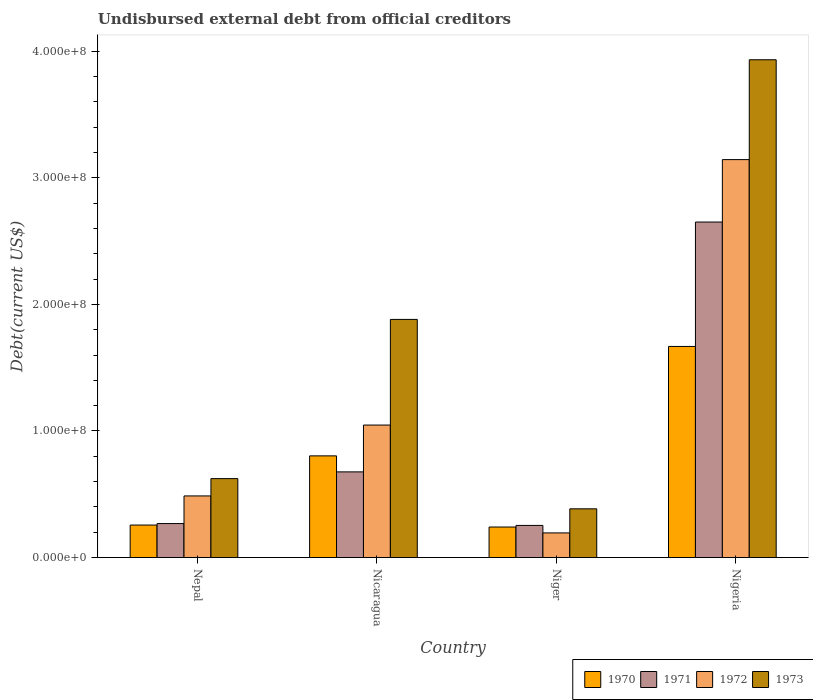How many different coloured bars are there?
Keep it short and to the point. 4. How many groups of bars are there?
Keep it short and to the point. 4. Are the number of bars on each tick of the X-axis equal?
Ensure brevity in your answer.  Yes. What is the label of the 3rd group of bars from the left?
Keep it short and to the point. Niger. What is the total debt in 1971 in Niger?
Provide a short and direct response. 2.54e+07. Across all countries, what is the maximum total debt in 1971?
Keep it short and to the point. 2.65e+08. Across all countries, what is the minimum total debt in 1972?
Provide a short and direct response. 1.94e+07. In which country was the total debt in 1972 maximum?
Your answer should be very brief. Nigeria. In which country was the total debt in 1971 minimum?
Your answer should be compact. Niger. What is the total total debt in 1971 in the graph?
Make the answer very short. 3.85e+08. What is the difference between the total debt in 1971 in Nepal and that in Nigeria?
Ensure brevity in your answer.  -2.38e+08. What is the difference between the total debt in 1971 in Nicaragua and the total debt in 1972 in Nigeria?
Keep it short and to the point. -2.47e+08. What is the average total debt in 1970 per country?
Your response must be concise. 7.42e+07. What is the difference between the total debt of/in 1973 and total debt of/in 1971 in Nicaragua?
Offer a terse response. 1.20e+08. In how many countries, is the total debt in 1973 greater than 40000000 US$?
Your response must be concise. 3. What is the ratio of the total debt in 1970 in Niger to that in Nigeria?
Offer a very short reply. 0.14. Is the difference between the total debt in 1973 in Nicaragua and Nigeria greater than the difference between the total debt in 1971 in Nicaragua and Nigeria?
Ensure brevity in your answer.  No. What is the difference between the highest and the second highest total debt in 1971?
Your answer should be very brief. 1.97e+08. What is the difference between the highest and the lowest total debt in 1970?
Keep it short and to the point. 1.43e+08. In how many countries, is the total debt in 1971 greater than the average total debt in 1971 taken over all countries?
Your answer should be compact. 1. Is it the case that in every country, the sum of the total debt in 1972 and total debt in 1973 is greater than the sum of total debt in 1971 and total debt in 1970?
Provide a short and direct response. No. What does the 3rd bar from the left in Nepal represents?
Keep it short and to the point. 1972. Is it the case that in every country, the sum of the total debt in 1970 and total debt in 1971 is greater than the total debt in 1972?
Offer a terse response. Yes. How many countries are there in the graph?
Keep it short and to the point. 4. What is the difference between two consecutive major ticks on the Y-axis?
Give a very brief answer. 1.00e+08. Are the values on the major ticks of Y-axis written in scientific E-notation?
Provide a short and direct response. Yes. Does the graph contain grids?
Make the answer very short. No. What is the title of the graph?
Ensure brevity in your answer.  Undisbursed external debt from official creditors. Does "2014" appear as one of the legend labels in the graph?
Provide a short and direct response. No. What is the label or title of the X-axis?
Make the answer very short. Country. What is the label or title of the Y-axis?
Your answer should be compact. Debt(current US$). What is the Debt(current US$) of 1970 in Nepal?
Provide a succinct answer. 2.57e+07. What is the Debt(current US$) in 1971 in Nepal?
Keep it short and to the point. 2.68e+07. What is the Debt(current US$) in 1972 in Nepal?
Give a very brief answer. 4.87e+07. What is the Debt(current US$) in 1973 in Nepal?
Offer a terse response. 6.23e+07. What is the Debt(current US$) in 1970 in Nicaragua?
Offer a very short reply. 8.03e+07. What is the Debt(current US$) in 1971 in Nicaragua?
Make the answer very short. 6.77e+07. What is the Debt(current US$) in 1972 in Nicaragua?
Provide a succinct answer. 1.05e+08. What is the Debt(current US$) in 1973 in Nicaragua?
Provide a succinct answer. 1.88e+08. What is the Debt(current US$) of 1970 in Niger?
Make the answer very short. 2.41e+07. What is the Debt(current US$) of 1971 in Niger?
Your response must be concise. 2.54e+07. What is the Debt(current US$) of 1972 in Niger?
Provide a succinct answer. 1.94e+07. What is the Debt(current US$) of 1973 in Niger?
Offer a very short reply. 3.85e+07. What is the Debt(current US$) in 1970 in Nigeria?
Your answer should be compact. 1.67e+08. What is the Debt(current US$) of 1971 in Nigeria?
Your response must be concise. 2.65e+08. What is the Debt(current US$) in 1972 in Nigeria?
Offer a very short reply. 3.14e+08. What is the Debt(current US$) in 1973 in Nigeria?
Your answer should be compact. 3.93e+08. Across all countries, what is the maximum Debt(current US$) in 1970?
Keep it short and to the point. 1.67e+08. Across all countries, what is the maximum Debt(current US$) in 1971?
Make the answer very short. 2.65e+08. Across all countries, what is the maximum Debt(current US$) of 1972?
Your answer should be very brief. 3.14e+08. Across all countries, what is the maximum Debt(current US$) in 1973?
Your response must be concise. 3.93e+08. Across all countries, what is the minimum Debt(current US$) of 1970?
Make the answer very short. 2.41e+07. Across all countries, what is the minimum Debt(current US$) in 1971?
Provide a succinct answer. 2.54e+07. Across all countries, what is the minimum Debt(current US$) in 1972?
Offer a very short reply. 1.94e+07. Across all countries, what is the minimum Debt(current US$) of 1973?
Your response must be concise. 3.85e+07. What is the total Debt(current US$) in 1970 in the graph?
Offer a terse response. 2.97e+08. What is the total Debt(current US$) in 1971 in the graph?
Your answer should be compact. 3.85e+08. What is the total Debt(current US$) of 1972 in the graph?
Offer a terse response. 4.87e+08. What is the total Debt(current US$) in 1973 in the graph?
Offer a terse response. 6.82e+08. What is the difference between the Debt(current US$) in 1970 in Nepal and that in Nicaragua?
Your answer should be very brief. -5.47e+07. What is the difference between the Debt(current US$) in 1971 in Nepal and that in Nicaragua?
Your answer should be compact. -4.08e+07. What is the difference between the Debt(current US$) in 1972 in Nepal and that in Nicaragua?
Your response must be concise. -5.60e+07. What is the difference between the Debt(current US$) in 1973 in Nepal and that in Nicaragua?
Your answer should be very brief. -1.26e+08. What is the difference between the Debt(current US$) of 1970 in Nepal and that in Niger?
Ensure brevity in your answer.  1.55e+06. What is the difference between the Debt(current US$) of 1971 in Nepal and that in Niger?
Your response must be concise. 1.45e+06. What is the difference between the Debt(current US$) of 1972 in Nepal and that in Niger?
Keep it short and to the point. 2.92e+07. What is the difference between the Debt(current US$) in 1973 in Nepal and that in Niger?
Your answer should be compact. 2.39e+07. What is the difference between the Debt(current US$) in 1970 in Nepal and that in Nigeria?
Your answer should be very brief. -1.41e+08. What is the difference between the Debt(current US$) of 1971 in Nepal and that in Nigeria?
Give a very brief answer. -2.38e+08. What is the difference between the Debt(current US$) of 1972 in Nepal and that in Nigeria?
Keep it short and to the point. -2.66e+08. What is the difference between the Debt(current US$) of 1973 in Nepal and that in Nigeria?
Provide a short and direct response. -3.31e+08. What is the difference between the Debt(current US$) in 1970 in Nicaragua and that in Niger?
Give a very brief answer. 5.62e+07. What is the difference between the Debt(current US$) of 1971 in Nicaragua and that in Niger?
Your answer should be compact. 4.23e+07. What is the difference between the Debt(current US$) of 1972 in Nicaragua and that in Niger?
Your answer should be compact. 8.52e+07. What is the difference between the Debt(current US$) in 1973 in Nicaragua and that in Niger?
Give a very brief answer. 1.50e+08. What is the difference between the Debt(current US$) in 1970 in Nicaragua and that in Nigeria?
Offer a very short reply. -8.65e+07. What is the difference between the Debt(current US$) of 1971 in Nicaragua and that in Nigeria?
Your answer should be very brief. -1.97e+08. What is the difference between the Debt(current US$) of 1972 in Nicaragua and that in Nigeria?
Offer a very short reply. -2.10e+08. What is the difference between the Debt(current US$) in 1973 in Nicaragua and that in Nigeria?
Your answer should be compact. -2.05e+08. What is the difference between the Debt(current US$) in 1970 in Niger and that in Nigeria?
Ensure brevity in your answer.  -1.43e+08. What is the difference between the Debt(current US$) in 1971 in Niger and that in Nigeria?
Your response must be concise. -2.40e+08. What is the difference between the Debt(current US$) of 1972 in Niger and that in Nigeria?
Provide a succinct answer. -2.95e+08. What is the difference between the Debt(current US$) of 1973 in Niger and that in Nigeria?
Your answer should be compact. -3.55e+08. What is the difference between the Debt(current US$) in 1970 in Nepal and the Debt(current US$) in 1971 in Nicaragua?
Make the answer very short. -4.20e+07. What is the difference between the Debt(current US$) of 1970 in Nepal and the Debt(current US$) of 1972 in Nicaragua?
Keep it short and to the point. -7.90e+07. What is the difference between the Debt(current US$) of 1970 in Nepal and the Debt(current US$) of 1973 in Nicaragua?
Your answer should be compact. -1.62e+08. What is the difference between the Debt(current US$) of 1971 in Nepal and the Debt(current US$) of 1972 in Nicaragua?
Offer a terse response. -7.78e+07. What is the difference between the Debt(current US$) in 1971 in Nepal and the Debt(current US$) in 1973 in Nicaragua?
Keep it short and to the point. -1.61e+08. What is the difference between the Debt(current US$) of 1972 in Nepal and the Debt(current US$) of 1973 in Nicaragua?
Give a very brief answer. -1.39e+08. What is the difference between the Debt(current US$) of 1970 in Nepal and the Debt(current US$) of 1971 in Niger?
Your response must be concise. 2.78e+05. What is the difference between the Debt(current US$) in 1970 in Nepal and the Debt(current US$) in 1972 in Niger?
Ensure brevity in your answer.  6.20e+06. What is the difference between the Debt(current US$) of 1970 in Nepal and the Debt(current US$) of 1973 in Niger?
Make the answer very short. -1.28e+07. What is the difference between the Debt(current US$) in 1971 in Nepal and the Debt(current US$) in 1972 in Niger?
Give a very brief answer. 7.37e+06. What is the difference between the Debt(current US$) in 1971 in Nepal and the Debt(current US$) in 1973 in Niger?
Offer a terse response. -1.17e+07. What is the difference between the Debt(current US$) in 1972 in Nepal and the Debt(current US$) in 1973 in Niger?
Your answer should be compact. 1.02e+07. What is the difference between the Debt(current US$) in 1970 in Nepal and the Debt(current US$) in 1971 in Nigeria?
Your response must be concise. -2.39e+08. What is the difference between the Debt(current US$) of 1970 in Nepal and the Debt(current US$) of 1972 in Nigeria?
Ensure brevity in your answer.  -2.89e+08. What is the difference between the Debt(current US$) in 1970 in Nepal and the Debt(current US$) in 1973 in Nigeria?
Provide a succinct answer. -3.68e+08. What is the difference between the Debt(current US$) in 1971 in Nepal and the Debt(current US$) in 1972 in Nigeria?
Your response must be concise. -2.88e+08. What is the difference between the Debt(current US$) in 1971 in Nepal and the Debt(current US$) in 1973 in Nigeria?
Give a very brief answer. -3.66e+08. What is the difference between the Debt(current US$) in 1972 in Nepal and the Debt(current US$) in 1973 in Nigeria?
Provide a succinct answer. -3.45e+08. What is the difference between the Debt(current US$) in 1970 in Nicaragua and the Debt(current US$) in 1971 in Niger?
Your response must be concise. 5.49e+07. What is the difference between the Debt(current US$) of 1970 in Nicaragua and the Debt(current US$) of 1972 in Niger?
Your answer should be compact. 6.09e+07. What is the difference between the Debt(current US$) of 1970 in Nicaragua and the Debt(current US$) of 1973 in Niger?
Your response must be concise. 4.18e+07. What is the difference between the Debt(current US$) in 1971 in Nicaragua and the Debt(current US$) in 1972 in Niger?
Ensure brevity in your answer.  4.82e+07. What is the difference between the Debt(current US$) of 1971 in Nicaragua and the Debt(current US$) of 1973 in Niger?
Make the answer very short. 2.92e+07. What is the difference between the Debt(current US$) in 1972 in Nicaragua and the Debt(current US$) in 1973 in Niger?
Your answer should be very brief. 6.62e+07. What is the difference between the Debt(current US$) of 1970 in Nicaragua and the Debt(current US$) of 1971 in Nigeria?
Ensure brevity in your answer.  -1.85e+08. What is the difference between the Debt(current US$) of 1970 in Nicaragua and the Debt(current US$) of 1972 in Nigeria?
Your answer should be compact. -2.34e+08. What is the difference between the Debt(current US$) in 1970 in Nicaragua and the Debt(current US$) in 1973 in Nigeria?
Offer a very short reply. -3.13e+08. What is the difference between the Debt(current US$) of 1971 in Nicaragua and the Debt(current US$) of 1972 in Nigeria?
Your answer should be compact. -2.47e+08. What is the difference between the Debt(current US$) of 1971 in Nicaragua and the Debt(current US$) of 1973 in Nigeria?
Your answer should be compact. -3.26e+08. What is the difference between the Debt(current US$) of 1972 in Nicaragua and the Debt(current US$) of 1973 in Nigeria?
Offer a terse response. -2.89e+08. What is the difference between the Debt(current US$) in 1970 in Niger and the Debt(current US$) in 1971 in Nigeria?
Offer a very short reply. -2.41e+08. What is the difference between the Debt(current US$) of 1970 in Niger and the Debt(current US$) of 1972 in Nigeria?
Provide a short and direct response. -2.90e+08. What is the difference between the Debt(current US$) in 1970 in Niger and the Debt(current US$) in 1973 in Nigeria?
Your answer should be compact. -3.69e+08. What is the difference between the Debt(current US$) in 1971 in Niger and the Debt(current US$) in 1972 in Nigeria?
Ensure brevity in your answer.  -2.89e+08. What is the difference between the Debt(current US$) in 1971 in Niger and the Debt(current US$) in 1973 in Nigeria?
Offer a terse response. -3.68e+08. What is the difference between the Debt(current US$) in 1972 in Niger and the Debt(current US$) in 1973 in Nigeria?
Keep it short and to the point. -3.74e+08. What is the average Debt(current US$) of 1970 per country?
Give a very brief answer. 7.42e+07. What is the average Debt(current US$) of 1971 per country?
Keep it short and to the point. 9.62e+07. What is the average Debt(current US$) of 1972 per country?
Offer a terse response. 1.22e+08. What is the average Debt(current US$) of 1973 per country?
Ensure brevity in your answer.  1.71e+08. What is the difference between the Debt(current US$) of 1970 and Debt(current US$) of 1971 in Nepal?
Make the answer very short. -1.17e+06. What is the difference between the Debt(current US$) in 1970 and Debt(current US$) in 1972 in Nepal?
Offer a very short reply. -2.30e+07. What is the difference between the Debt(current US$) in 1970 and Debt(current US$) in 1973 in Nepal?
Your response must be concise. -3.67e+07. What is the difference between the Debt(current US$) in 1971 and Debt(current US$) in 1972 in Nepal?
Ensure brevity in your answer.  -2.18e+07. What is the difference between the Debt(current US$) in 1971 and Debt(current US$) in 1973 in Nepal?
Give a very brief answer. -3.55e+07. What is the difference between the Debt(current US$) in 1972 and Debt(current US$) in 1973 in Nepal?
Make the answer very short. -1.37e+07. What is the difference between the Debt(current US$) of 1970 and Debt(current US$) of 1971 in Nicaragua?
Provide a succinct answer. 1.26e+07. What is the difference between the Debt(current US$) in 1970 and Debt(current US$) in 1972 in Nicaragua?
Offer a very short reply. -2.44e+07. What is the difference between the Debt(current US$) in 1970 and Debt(current US$) in 1973 in Nicaragua?
Offer a terse response. -1.08e+08. What is the difference between the Debt(current US$) in 1971 and Debt(current US$) in 1972 in Nicaragua?
Your answer should be compact. -3.70e+07. What is the difference between the Debt(current US$) in 1971 and Debt(current US$) in 1973 in Nicaragua?
Your answer should be compact. -1.20e+08. What is the difference between the Debt(current US$) of 1972 and Debt(current US$) of 1973 in Nicaragua?
Offer a very short reply. -8.35e+07. What is the difference between the Debt(current US$) in 1970 and Debt(current US$) in 1971 in Niger?
Offer a terse response. -1.28e+06. What is the difference between the Debt(current US$) of 1970 and Debt(current US$) of 1972 in Niger?
Your response must be concise. 4.65e+06. What is the difference between the Debt(current US$) of 1970 and Debt(current US$) of 1973 in Niger?
Offer a very short reply. -1.44e+07. What is the difference between the Debt(current US$) in 1971 and Debt(current US$) in 1972 in Niger?
Offer a very short reply. 5.93e+06. What is the difference between the Debt(current US$) of 1971 and Debt(current US$) of 1973 in Niger?
Give a very brief answer. -1.31e+07. What is the difference between the Debt(current US$) in 1972 and Debt(current US$) in 1973 in Niger?
Offer a very short reply. -1.90e+07. What is the difference between the Debt(current US$) of 1970 and Debt(current US$) of 1971 in Nigeria?
Your answer should be compact. -9.83e+07. What is the difference between the Debt(current US$) in 1970 and Debt(current US$) in 1972 in Nigeria?
Keep it short and to the point. -1.48e+08. What is the difference between the Debt(current US$) of 1970 and Debt(current US$) of 1973 in Nigeria?
Your answer should be very brief. -2.27e+08. What is the difference between the Debt(current US$) in 1971 and Debt(current US$) in 1972 in Nigeria?
Provide a succinct answer. -4.93e+07. What is the difference between the Debt(current US$) in 1971 and Debt(current US$) in 1973 in Nigeria?
Offer a very short reply. -1.28e+08. What is the difference between the Debt(current US$) of 1972 and Debt(current US$) of 1973 in Nigeria?
Offer a very short reply. -7.89e+07. What is the ratio of the Debt(current US$) in 1970 in Nepal to that in Nicaragua?
Provide a short and direct response. 0.32. What is the ratio of the Debt(current US$) in 1971 in Nepal to that in Nicaragua?
Make the answer very short. 0.4. What is the ratio of the Debt(current US$) in 1972 in Nepal to that in Nicaragua?
Your response must be concise. 0.46. What is the ratio of the Debt(current US$) in 1973 in Nepal to that in Nicaragua?
Offer a very short reply. 0.33. What is the ratio of the Debt(current US$) of 1970 in Nepal to that in Niger?
Keep it short and to the point. 1.06. What is the ratio of the Debt(current US$) in 1971 in Nepal to that in Niger?
Ensure brevity in your answer.  1.06. What is the ratio of the Debt(current US$) of 1972 in Nepal to that in Niger?
Make the answer very short. 2.5. What is the ratio of the Debt(current US$) in 1973 in Nepal to that in Niger?
Offer a very short reply. 1.62. What is the ratio of the Debt(current US$) of 1970 in Nepal to that in Nigeria?
Offer a very short reply. 0.15. What is the ratio of the Debt(current US$) of 1971 in Nepal to that in Nigeria?
Offer a very short reply. 0.1. What is the ratio of the Debt(current US$) in 1972 in Nepal to that in Nigeria?
Offer a very short reply. 0.15. What is the ratio of the Debt(current US$) of 1973 in Nepal to that in Nigeria?
Your response must be concise. 0.16. What is the ratio of the Debt(current US$) in 1970 in Nicaragua to that in Niger?
Your answer should be very brief. 3.33. What is the ratio of the Debt(current US$) of 1971 in Nicaragua to that in Niger?
Offer a terse response. 2.67. What is the ratio of the Debt(current US$) in 1972 in Nicaragua to that in Niger?
Your answer should be very brief. 5.38. What is the ratio of the Debt(current US$) of 1973 in Nicaragua to that in Niger?
Make the answer very short. 4.89. What is the ratio of the Debt(current US$) of 1970 in Nicaragua to that in Nigeria?
Give a very brief answer. 0.48. What is the ratio of the Debt(current US$) of 1971 in Nicaragua to that in Nigeria?
Provide a short and direct response. 0.26. What is the ratio of the Debt(current US$) of 1972 in Nicaragua to that in Nigeria?
Your answer should be very brief. 0.33. What is the ratio of the Debt(current US$) in 1973 in Nicaragua to that in Nigeria?
Your answer should be compact. 0.48. What is the ratio of the Debt(current US$) in 1970 in Niger to that in Nigeria?
Your answer should be very brief. 0.14. What is the ratio of the Debt(current US$) in 1971 in Niger to that in Nigeria?
Provide a succinct answer. 0.1. What is the ratio of the Debt(current US$) in 1972 in Niger to that in Nigeria?
Ensure brevity in your answer.  0.06. What is the ratio of the Debt(current US$) of 1973 in Niger to that in Nigeria?
Give a very brief answer. 0.1. What is the difference between the highest and the second highest Debt(current US$) in 1970?
Give a very brief answer. 8.65e+07. What is the difference between the highest and the second highest Debt(current US$) of 1971?
Offer a very short reply. 1.97e+08. What is the difference between the highest and the second highest Debt(current US$) in 1972?
Offer a terse response. 2.10e+08. What is the difference between the highest and the second highest Debt(current US$) of 1973?
Give a very brief answer. 2.05e+08. What is the difference between the highest and the lowest Debt(current US$) in 1970?
Offer a very short reply. 1.43e+08. What is the difference between the highest and the lowest Debt(current US$) of 1971?
Make the answer very short. 2.40e+08. What is the difference between the highest and the lowest Debt(current US$) in 1972?
Offer a terse response. 2.95e+08. What is the difference between the highest and the lowest Debt(current US$) of 1973?
Offer a very short reply. 3.55e+08. 